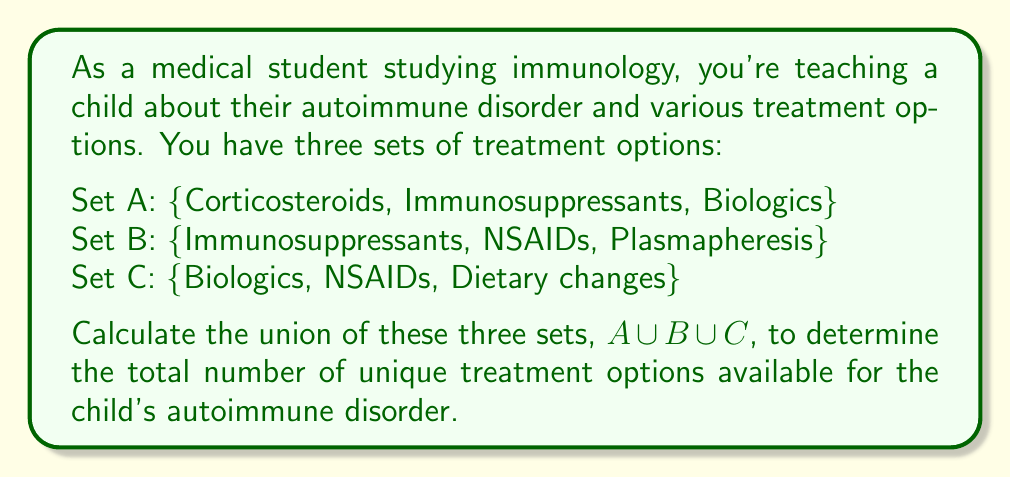Solve this math problem. To solve this problem, we need to find the union of sets A, B, and C. The union of sets includes all unique elements from all sets, without repetition. Let's follow these steps:

1. List all elements from set A:
   {Corticosteroids, Immunosuppressants, Biologics}

2. Add unique elements from set B:
   {Corticosteroids, Immunosuppressants, Biologics, NSAIDs, Plasmapheresis}

3. Add unique elements from set C:
   {Corticosteroids, Immunosuppressants, Biologics, NSAIDs, Plasmapheresis, Dietary changes}

4. Count the total number of unique elements in the resulting set.

We can represent this mathematically as:

$$A \cup B \cup C = \{x : x \in A \text{ or } x \in B \text{ or } x \in C\}$$

In this case, we have:

$$A \cup B \cup C = \{\text{Corticosteroids, Immunosuppressants, Biologics, NSAIDs, Plasmapheresis, Dietary changes}\}$$

The total number of unique elements in this set is 6.
Answer: The union of sets A, B, and C contains 6 unique treatment options. 